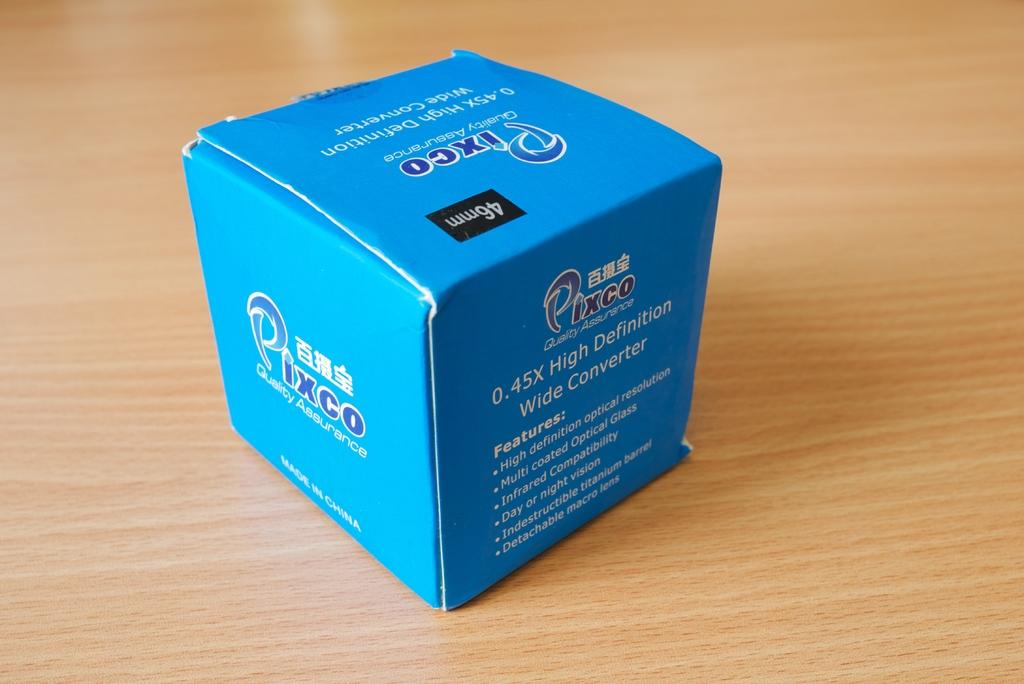<image>
Provide a brief description of the given image. A blue box with Pixco and asian text written on it. 